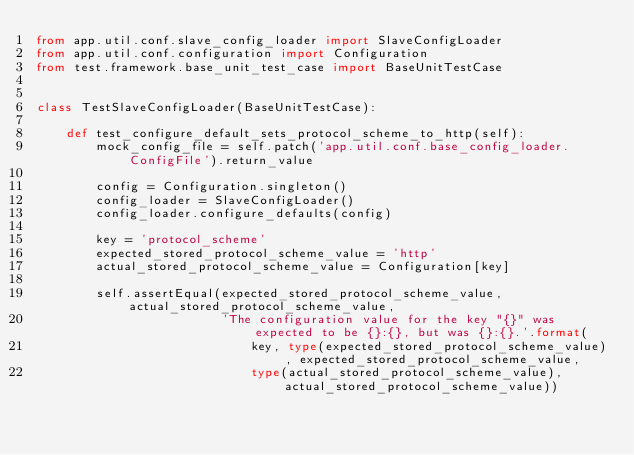Convert code to text. <code><loc_0><loc_0><loc_500><loc_500><_Python_>from app.util.conf.slave_config_loader import SlaveConfigLoader
from app.util.conf.configuration import Configuration
from test.framework.base_unit_test_case import BaseUnitTestCase


class TestSlaveConfigLoader(BaseUnitTestCase):

    def test_configure_default_sets_protocol_scheme_to_http(self):
        mock_config_file = self.patch('app.util.conf.base_config_loader.ConfigFile').return_value

        config = Configuration.singleton()
        config_loader = SlaveConfigLoader()
        config_loader.configure_defaults(config)

        key = 'protocol_scheme'
        expected_stored_protocol_scheme_value = 'http'
        actual_stored_protocol_scheme_value = Configuration[key]

        self.assertEqual(expected_stored_protocol_scheme_value, actual_stored_protocol_scheme_value,
                         'The configuration value for the key "{}" was expected to be {}:{}, but was {}:{}.'.format(
                             key, type(expected_stored_protocol_scheme_value), expected_stored_protocol_scheme_value,
                             type(actual_stored_protocol_scheme_value), actual_stored_protocol_scheme_value))
</code> 